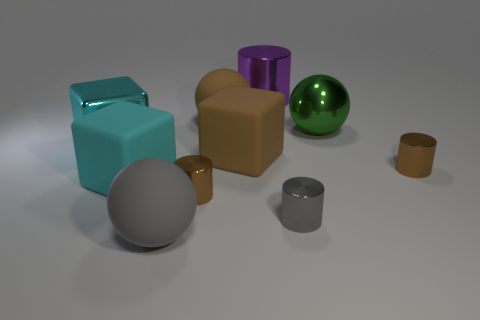There is a matte ball in front of the cyan metal cube; does it have the same size as the gray metallic cylinder?
Make the answer very short. No. Do the large block that is in front of the big brown block and the big metallic cube have the same color?
Offer a very short reply. Yes. Do the green object and the gray metallic cylinder have the same size?
Give a very brief answer. No. What number of tiny gray cylinders have the same material as the small gray thing?
Your answer should be very brief. 0. There is a brown thing that is the same shape as the gray matte object; what is its size?
Make the answer very short. Large. There is a large brown rubber object that is in front of the large cyan metal block; is its shape the same as the tiny gray metallic object?
Provide a short and direct response. No. There is a gray thing that is to the right of the big matte sphere that is in front of the big cyan metal block; what is its shape?
Offer a very short reply. Cylinder. Are there any other things that are the same shape as the large gray matte thing?
Give a very brief answer. Yes. What is the color of the other large rubber thing that is the same shape as the large gray thing?
Your response must be concise. Brown. Does the big metal block have the same color as the tiny cylinder that is right of the green object?
Ensure brevity in your answer.  No. 